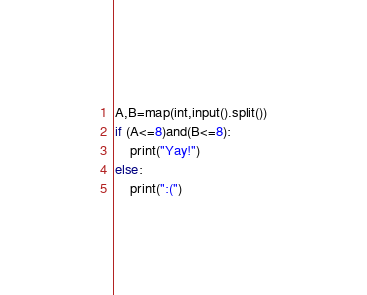<code> <loc_0><loc_0><loc_500><loc_500><_Python_>A,B=map(int,input().split())
if (A<=8)and(B<=8):
    print("Yay!")
else:
    print(":(")</code> 